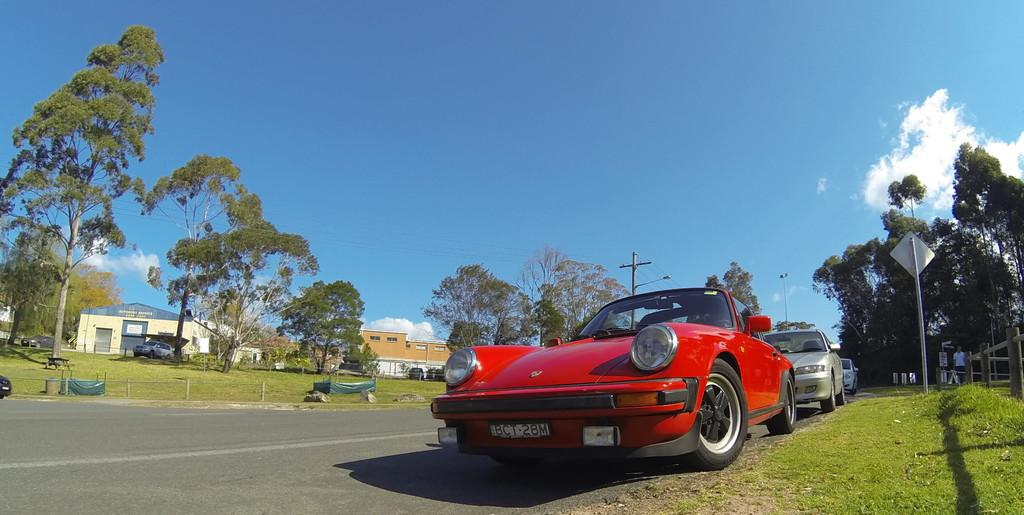What is the main feature of the image? There is a road in the image. What else can be seen on the road? Vehicles are present in the image. What structures are visible alongside the road? There are poles and buildings in the image. What type of vegetation is present in the image? Trees and grass are visible in the image. What is visible in the background of the image? The sky is visible in the background of the image. What objects can be found on the ground in the image? There are objects on the ground in the image. What type of zinc can be seen in the image? There is no zinc present in the image. How many bees can be seen flying around the trees in the image? There are no bees visible in the image. 